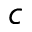<formula> <loc_0><loc_0><loc_500><loc_500>c</formula> 